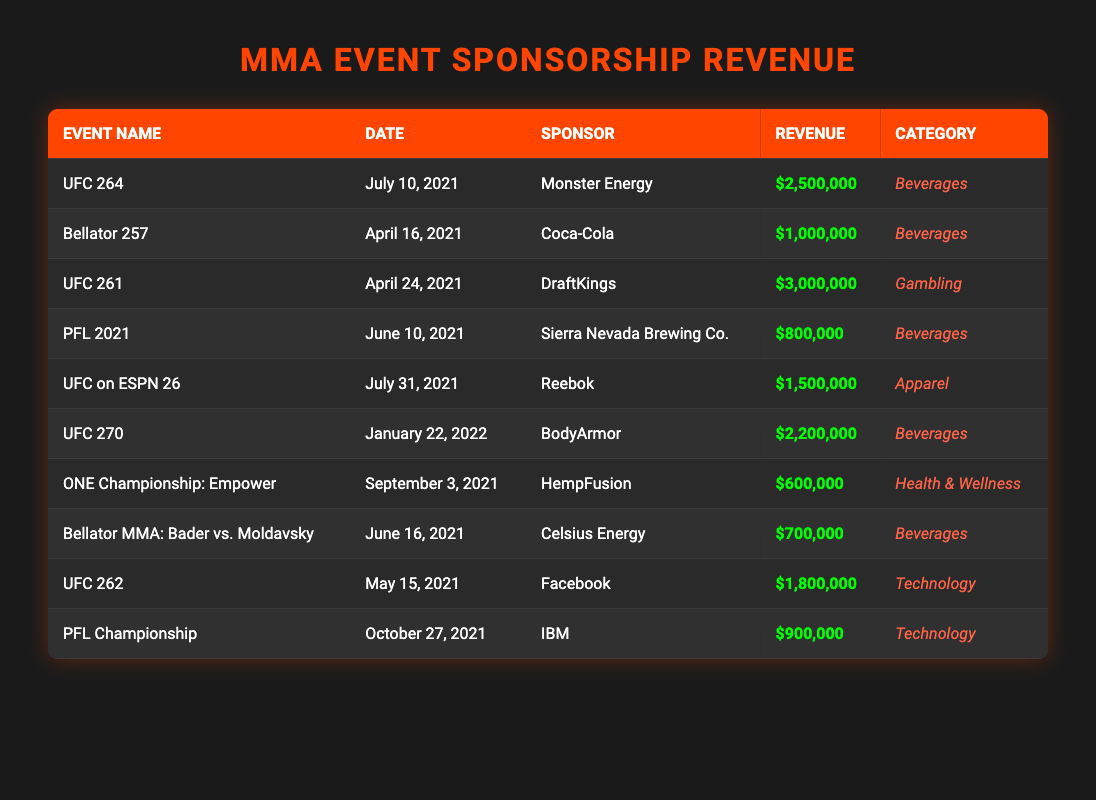What is the total sponsorship revenue from the MMA events in the table? To find the total revenue, I need to sum all the individual revenue amounts in the table. The revenues are as follows: $2,500,000 + $1,000,000 + $3,000,000 + $800,000 + $1,500,000 + $2,200,000 + $600,000 + $700,000 + $1,800,000 + $900,000, which equals $16,200,000.
Answer: $16,200,000 Which event had the highest sponsorship revenue? By looking at the revenue figures for each event, UFC 261 has the highest revenue at $3,000,000. None of the other events exceeded this amount.
Answer: UFC 261 How many sponsors provided revenue for MMA events? I can count the unique sponsors listed in the table: Monster Energy, Coca-Cola, DraftKings, Sierra Nevada Brewing Co., Reebok, BodyArmor, HempFusion, Celsius Energy, Facebook, and IBM, making a total of 10 distinct sponsors.
Answer: 10 What was the average revenue per event? I divide the total revenue by the number of events. The total revenue is $16,200,000 and there are 10 events, so the average revenue is $16,200,000 / 10 = $1,620,000.
Answer: $1,620,000 Did any beverage sponsor generate revenue greater than $2,000,000? Reviewing the list of beverage sponsors, only Monster Energy and BodyArmor are relevant. However, Monster Energy ($2,500,000) and BodyArmor ($2,200,000) both exceed $2,000,000, confirming that at least one did.
Answer: Yes What is the revenue difference between the highest and lowest earning events? The highest earning event is UFC 261 with $3,000,000, and the lowest is HempFusion from ONE Championship: Empower with $600,000. Therefore, the difference is $3,000,000 - $600,000 = $2,400,000.
Answer: $2,400,000 Which category had the most total revenue from sponsorships? To find the total revenue for each category, I sum the revenue for each category: Beverages: $2,500,000 + $1,000,000 + $800,000 + $2,200,000 + $700,000 = $7,200,000; Gambling: $3,000,000; Apparel: $1,500,000; Health & Wellness: $600,000; Technology: $1,800,000 + $900,000 = $2,700,000. The highest total is from Beverages at $7,200,000.
Answer: Beverages What percentage of the total revenue was contributed by DraftKings? DraftKings contributed $3,000,000. To find the percentage, I use the formula: ($3,000,000 / $16,200,000) * 100, which equals approximately 18.52%.
Answer: 18.52% Which event took place in June 2021 and what was its sponsorship revenue? In June 2021, two events took place: PFL 2021 with a revenue of $800,000 and Bellator MMA: Bader vs. Moldavsky with a revenue of $700,000. Both events’ revenues can be mentioned for clarity.
Answer: PFL 2021 ($800,000) and Bellator MMA: Bader vs. Moldavsky ($700,000) 